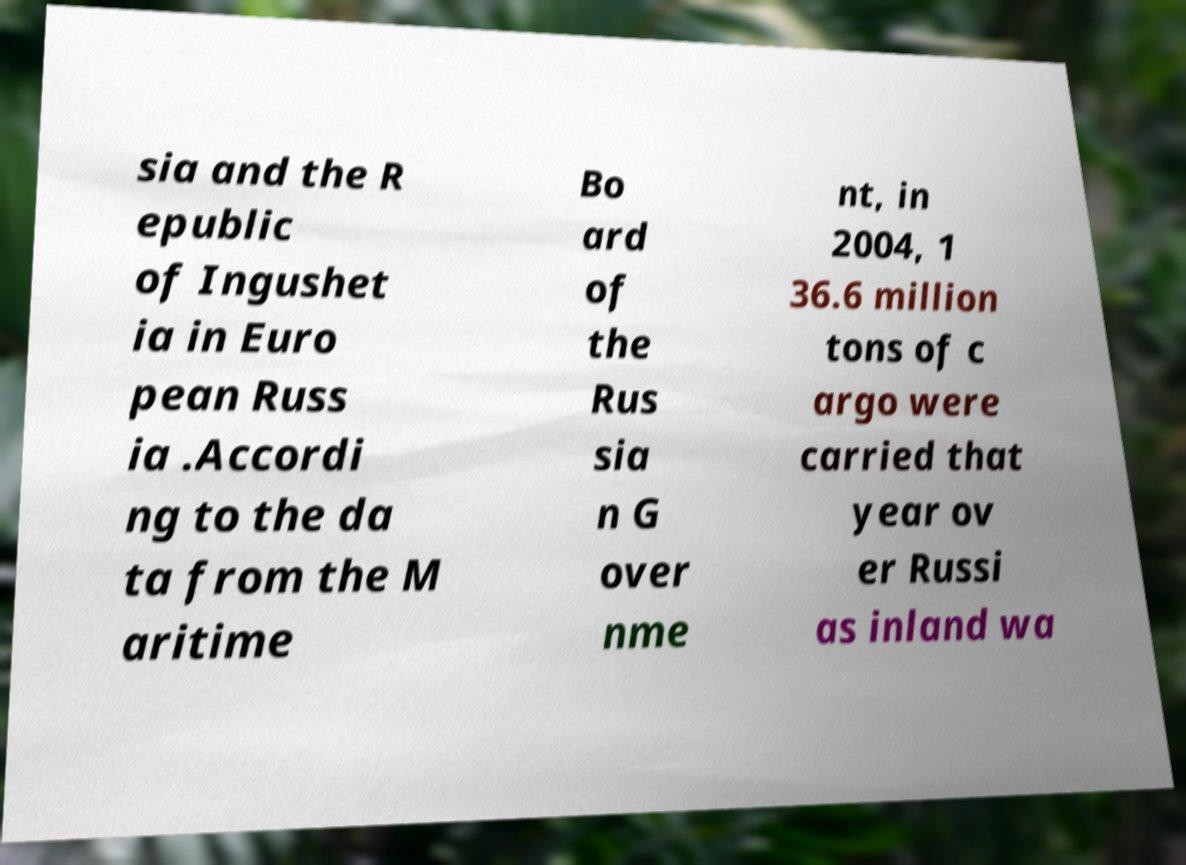Can you accurately transcribe the text from the provided image for me? sia and the R epublic of Ingushet ia in Euro pean Russ ia .Accordi ng to the da ta from the M aritime Bo ard of the Rus sia n G over nme nt, in 2004, 1 36.6 million tons of c argo were carried that year ov er Russi as inland wa 